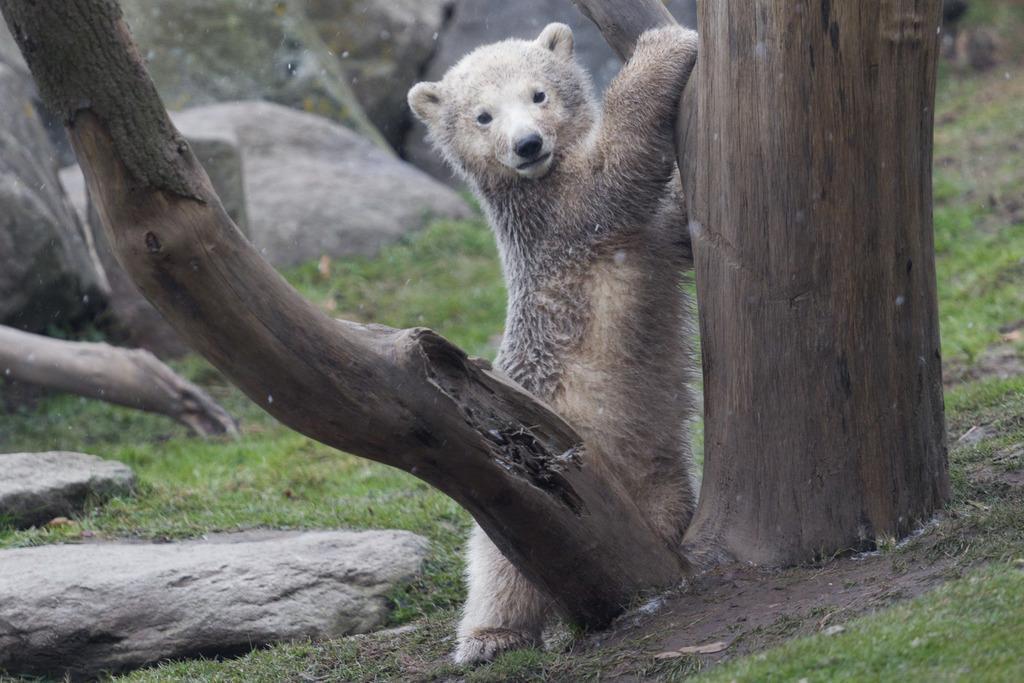Please provide a concise description of this image. In the picture I can see a polar bear on the ground. I can also see trees, the grass and rocks. 